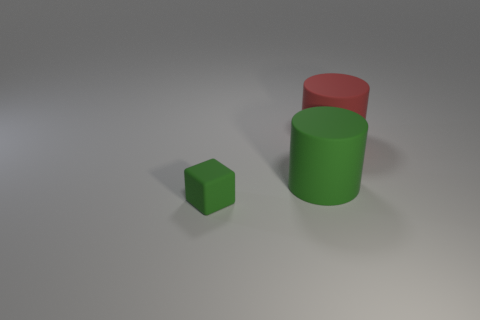Are there any other things that have the same color as the matte cube?
Offer a terse response. Yes. What number of green objects are either small matte blocks or big cylinders?
Your response must be concise. 2. Is the number of big cylinders left of the large red matte object less than the number of green cubes?
Your answer should be very brief. No. There is a green matte thing that is right of the green cube; what number of rubber objects are in front of it?
Your answer should be very brief. 1. What number of other objects are the same size as the green matte cube?
Give a very brief answer. 0. What number of objects are either big cylinders or things behind the small thing?
Offer a terse response. 2. Are there fewer large red objects than tiny brown metal balls?
Provide a short and direct response. No. The big cylinder behind the green matte object to the right of the small rubber object is what color?
Make the answer very short. Red. There is a green object that is the same shape as the red object; what material is it?
Offer a very short reply. Rubber. How many matte objects are large red things or green blocks?
Keep it short and to the point. 2. 